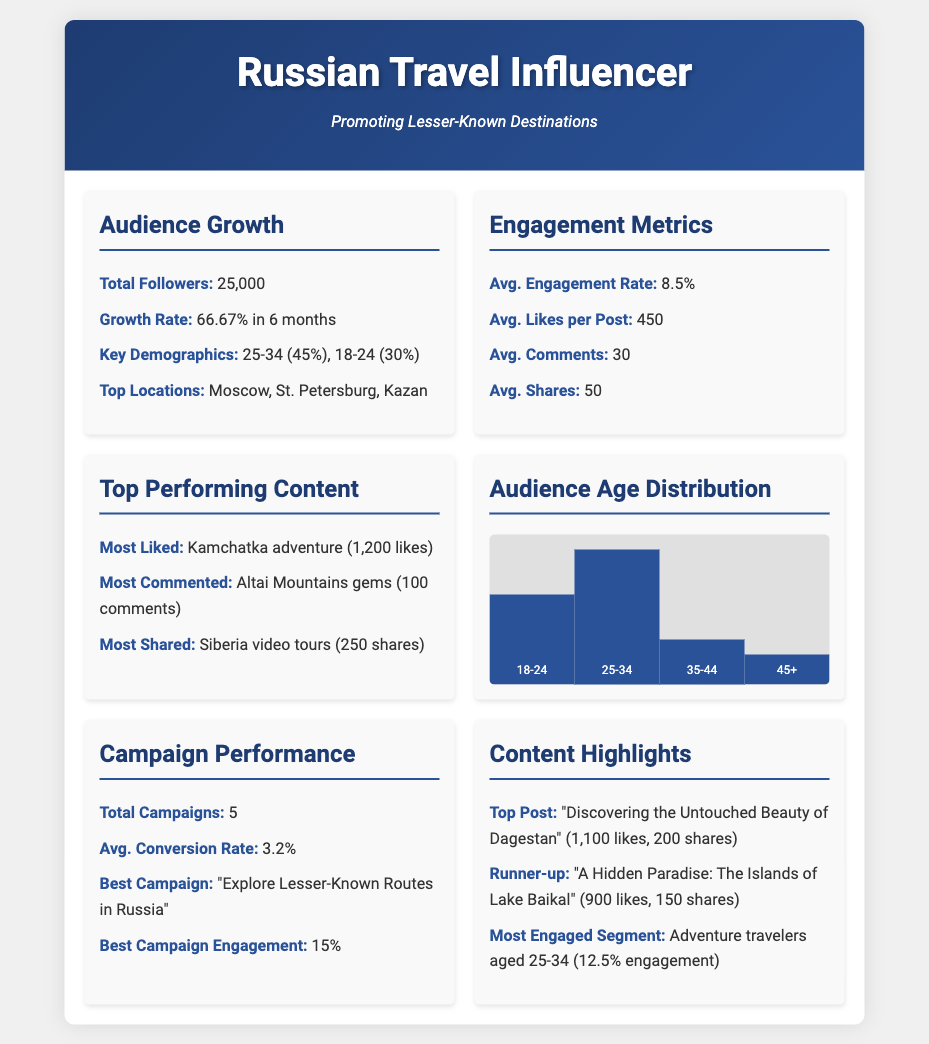What is the total number of followers? The total number of followers is directly provided in the document under the Audience Growth section.
Answer: 25,000 What is the growth rate over the past six months? The growth rate is stated as a percentage under the Audience Growth section.
Answer: 66.67% What is the average engagement rate? The average engagement rate can be found in the Engagement Metrics section of the document.
Answer: 8.5% What is the most liked content? The most liked content is specified in the Top Performing Content section.
Answer: Kamchatka adventure (1,200 likes) Which age group has the highest percentage in audience distribution? The age distribution chart indicates the highest percentage in the Audience Age Distribution section.
Answer: 25-34 How many campaigns were conducted in total? The total number of campaigns is provided in the Campaign Performance section.
Answer: 5 What is the average conversion rate? The average conversion rate is listed under the Campaign Performance section of the document.
Answer: 3.2% What content received the most comments? The document specifies the content with the most comments in the Top Performing Content section.
Answer: Altai Mountains gems (100 comments) 